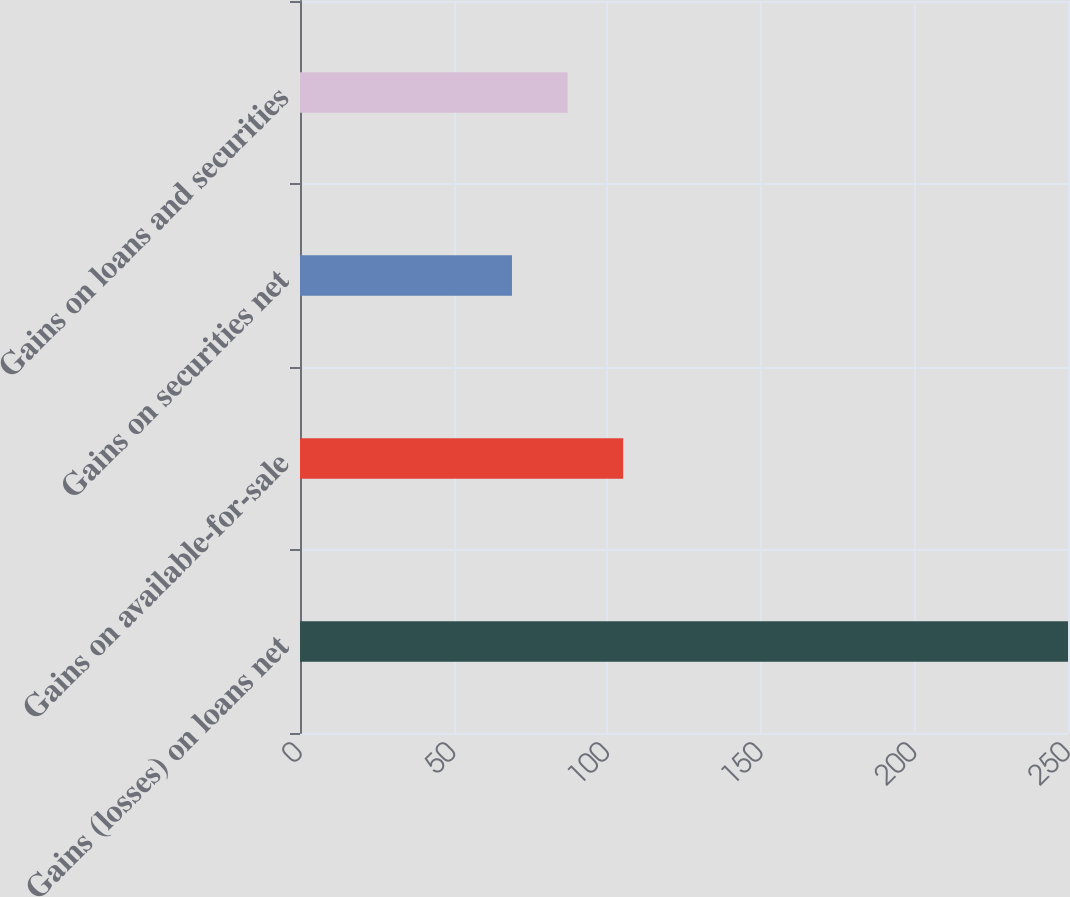Convert chart to OTSL. <chart><loc_0><loc_0><loc_500><loc_500><bar_chart><fcel>Gains (losses) on loans net<fcel>Gains on available-for-sale<fcel>Gains on securities net<fcel>Gains on loans and securities<nl><fcel>250<fcel>105.2<fcel>69<fcel>87.1<nl></chart> 